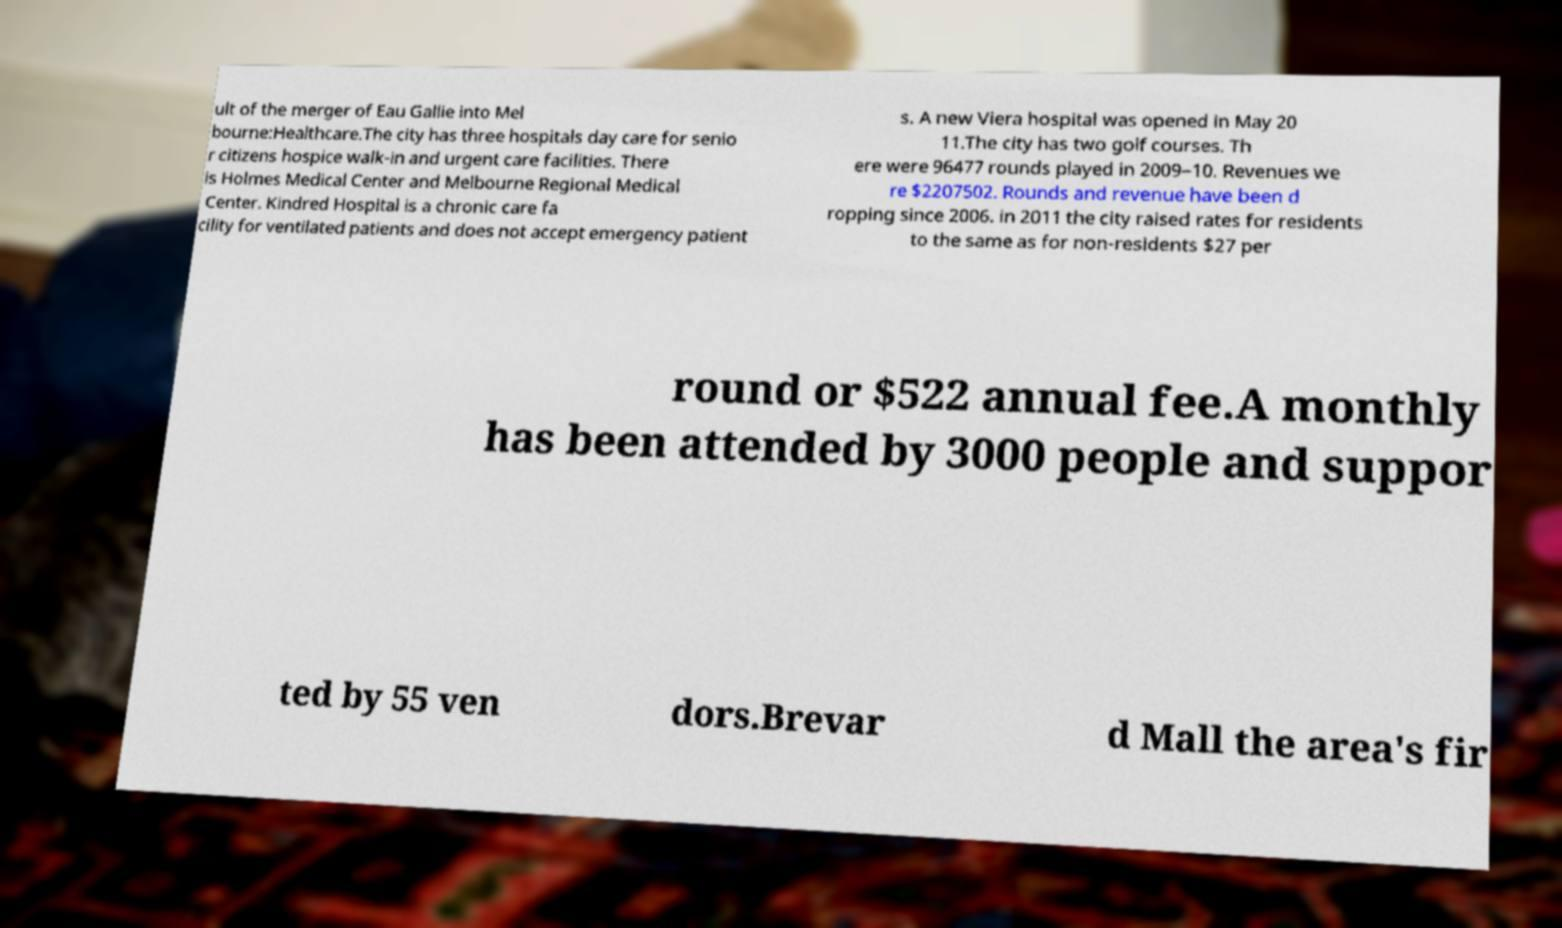Please identify and transcribe the text found in this image. ult of the merger of Eau Gallie into Mel bourne:Healthcare.The city has three hospitals day care for senio r citizens hospice walk-in and urgent care facilities. There is Holmes Medical Center and Melbourne Regional Medical Center. Kindred Hospital is a chronic care fa cility for ventilated patients and does not accept emergency patient s. A new Viera hospital was opened in May 20 11.The city has two golf courses. Th ere were 96477 rounds played in 2009–10. Revenues we re $2207502. Rounds and revenue have been d ropping since 2006. in 2011 the city raised rates for residents to the same as for non-residents $27 per round or $522 annual fee.A monthly has been attended by 3000 people and suppor ted by 55 ven dors.Brevar d Mall the area's fir 